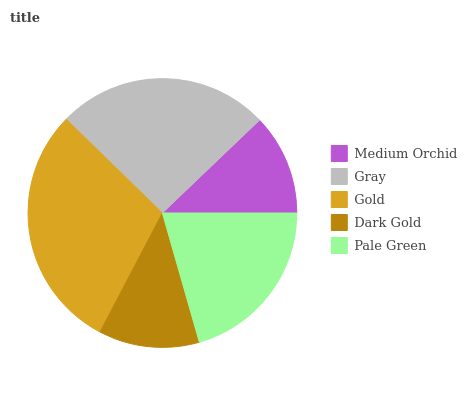Is Dark Gold the minimum?
Answer yes or no. Yes. Is Gold the maximum?
Answer yes or no. Yes. Is Gray the minimum?
Answer yes or no. No. Is Gray the maximum?
Answer yes or no. No. Is Gray greater than Medium Orchid?
Answer yes or no. Yes. Is Medium Orchid less than Gray?
Answer yes or no. Yes. Is Medium Orchid greater than Gray?
Answer yes or no. No. Is Gray less than Medium Orchid?
Answer yes or no. No. Is Pale Green the high median?
Answer yes or no. Yes. Is Pale Green the low median?
Answer yes or no. Yes. Is Medium Orchid the high median?
Answer yes or no. No. Is Dark Gold the low median?
Answer yes or no. No. 